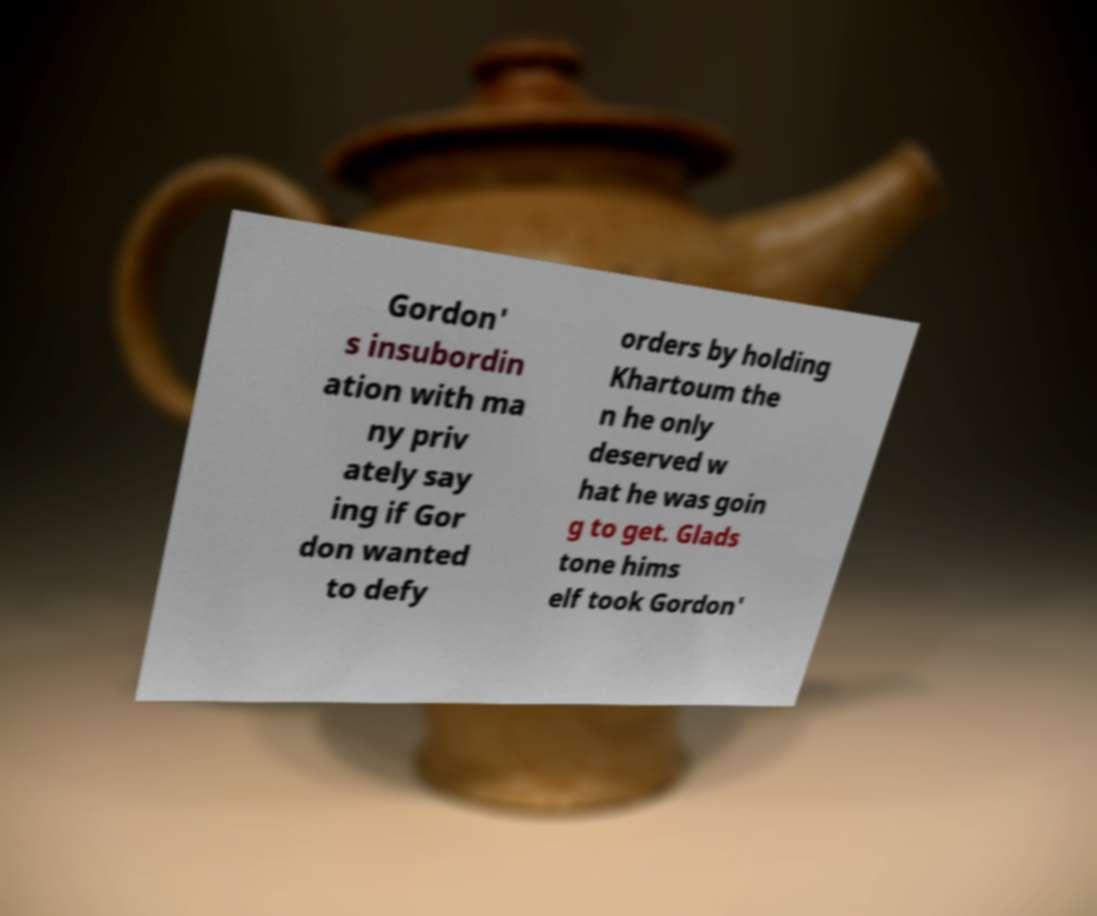Please identify and transcribe the text found in this image. Gordon' s insubordin ation with ma ny priv ately say ing if Gor don wanted to defy orders by holding Khartoum the n he only deserved w hat he was goin g to get. Glads tone hims elf took Gordon' 